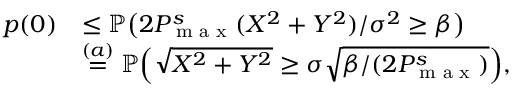<formula> <loc_0><loc_0><loc_500><loc_500>\begin{array} { r l } { p ( 0 ) } & { \leq \mathbb { P } \left ( 2 P _ { \max } ^ { s } ( X ^ { 2 } + Y ^ { 2 } ) / \sigma ^ { 2 } \geq \beta \right ) } \\ & { \stackrel { ( a ) } { = } \mathbb { P } \left ( \sqrt { X ^ { 2 } + Y ^ { 2 } } \geq \sigma \sqrt { \beta / ( 2 P _ { \max } ^ { s } ) } \right ) , } \end{array}</formula> 